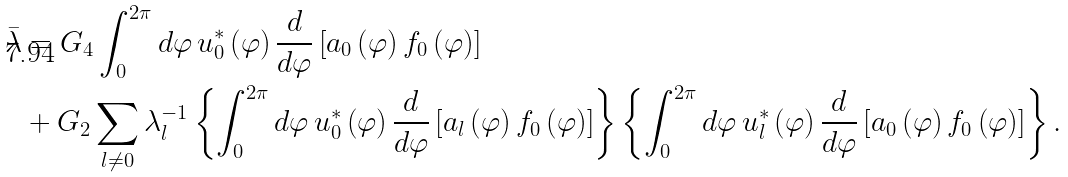Convert formula to latex. <formula><loc_0><loc_0><loc_500><loc_500>\bar { \lambda } & = G _ { 4 } \int _ { 0 } ^ { 2 \pi } d \varphi \, u _ { 0 } ^ { \ast } \left ( \varphi \right ) \frac { d } { d \varphi } \left [ a _ { 0 } \left ( \varphi \right ) f _ { 0 } \left ( \varphi \right ) \right ] \\ & + G _ { 2 } \sum _ { l \ne 0 } \lambda _ { l } ^ { - 1 } \left \{ \int _ { 0 } ^ { 2 \pi } d \varphi \, u _ { 0 } ^ { \ast } \left ( \varphi \right ) \frac { d } { d \varphi } \left [ a _ { l } \left ( \varphi \right ) f _ { 0 } \left ( \varphi \right ) \right ] \right \} \left \{ \int _ { 0 } ^ { 2 \pi } d \varphi \, u _ { l } ^ { \ast } \left ( \varphi \right ) \frac { d } { d \varphi } \left [ a _ { 0 } \left ( \varphi \right ) f _ { 0 } \left ( \varphi \right ) \right ] \right \} .</formula> 